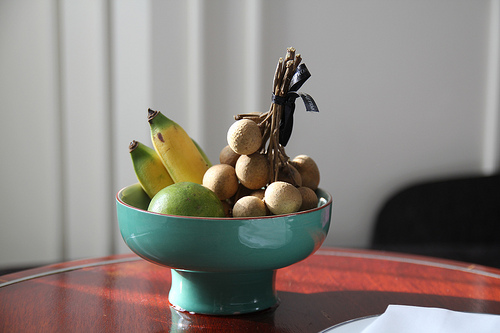<image>
Is the banana in the bowl? Yes. The banana is contained within or inside the bowl, showing a containment relationship. 